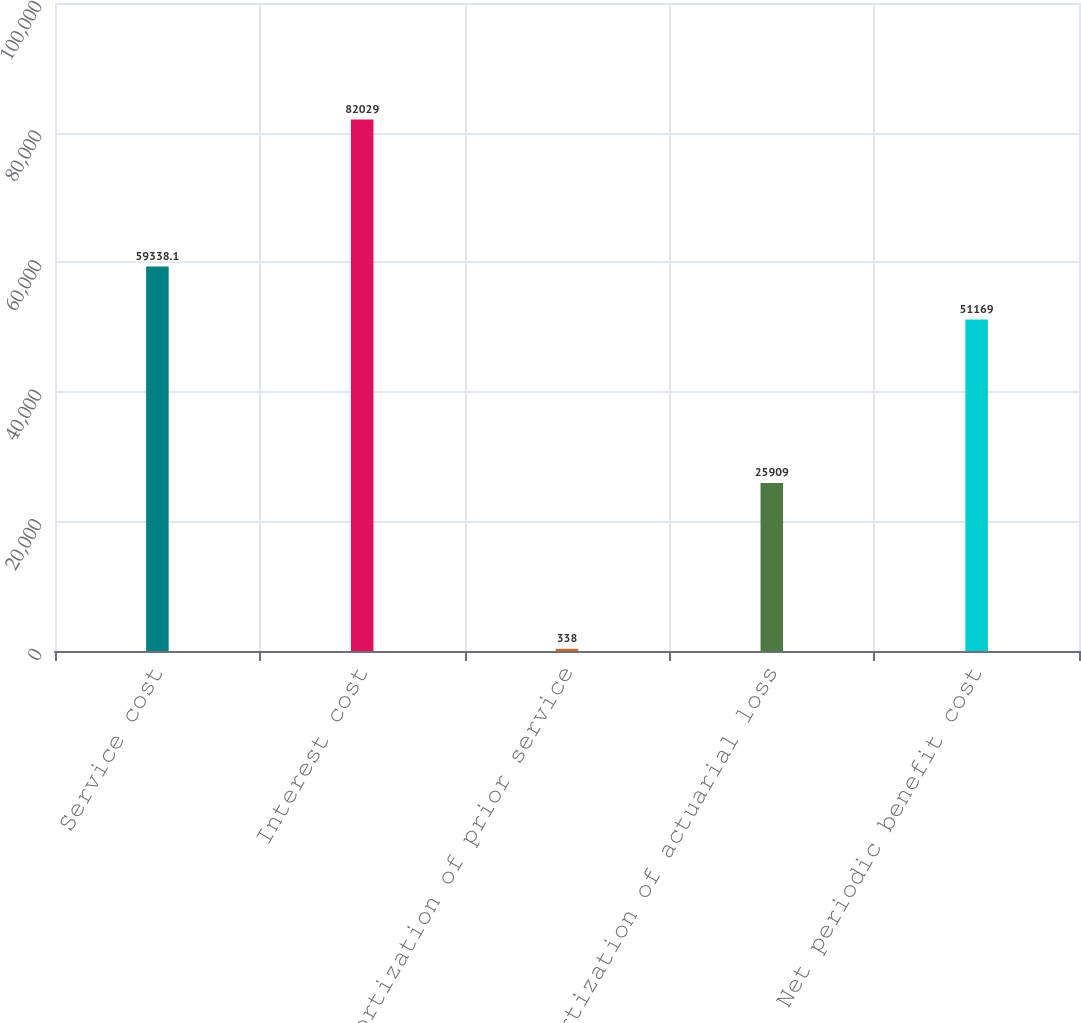<chart> <loc_0><loc_0><loc_500><loc_500><bar_chart><fcel>Service cost<fcel>Interest cost<fcel>Amortization of prior service<fcel>Amortization of actuarial loss<fcel>Net periodic benefit cost<nl><fcel>59338.1<fcel>82029<fcel>338<fcel>25909<fcel>51169<nl></chart> 